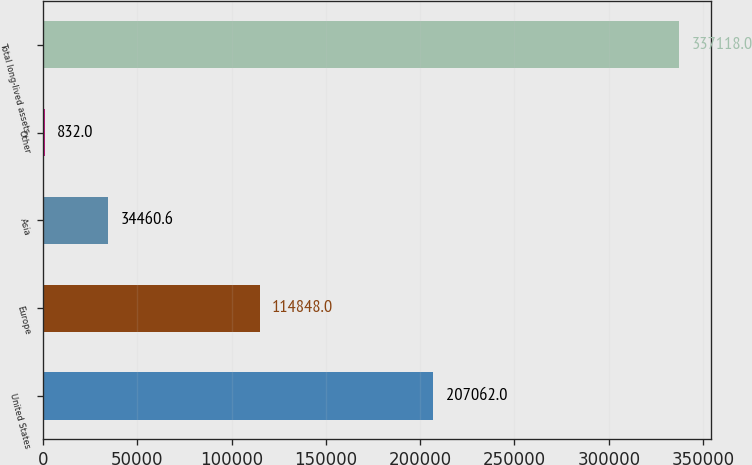<chart> <loc_0><loc_0><loc_500><loc_500><bar_chart><fcel>United States<fcel>Europe<fcel>Asia<fcel>Other<fcel>Total long-lived assets<nl><fcel>207062<fcel>114848<fcel>34460.6<fcel>832<fcel>337118<nl></chart> 